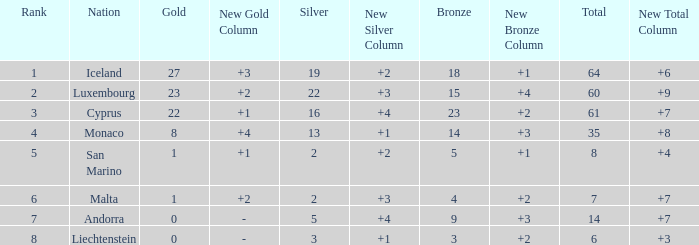How many bronzes for nations with over 22 golds and ranked under 2? 18.0. 